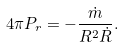<formula> <loc_0><loc_0><loc_500><loc_500>4 \pi P _ { r } = - \frac { \dot { m } } { R ^ { 2 } \dot { R } } .</formula> 